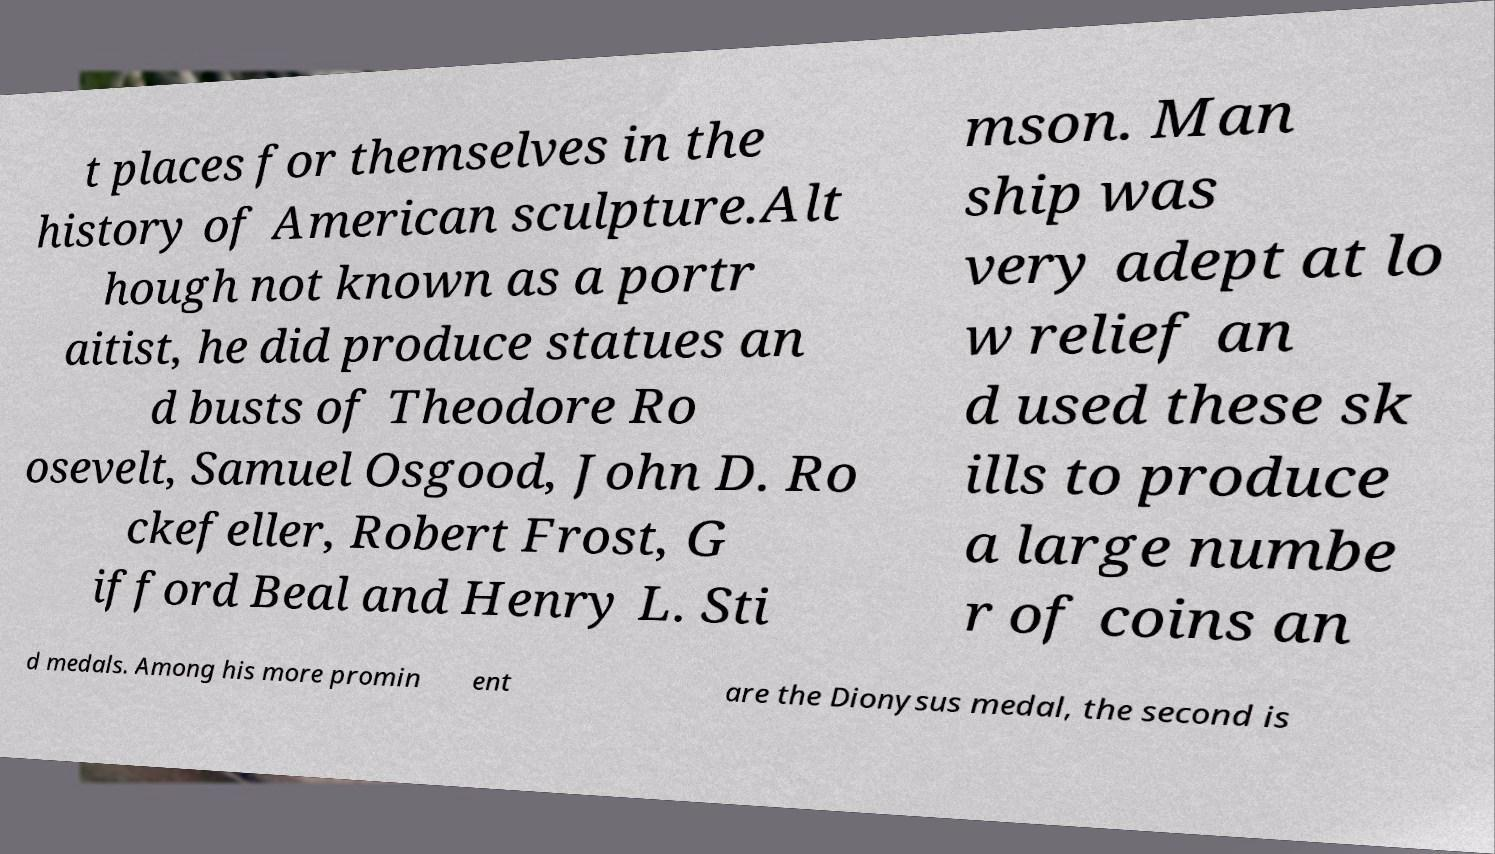Could you extract and type out the text from this image? t places for themselves in the history of American sculpture.Alt hough not known as a portr aitist, he did produce statues an d busts of Theodore Ro osevelt, Samuel Osgood, John D. Ro ckefeller, Robert Frost, G ifford Beal and Henry L. Sti mson. Man ship was very adept at lo w relief an d used these sk ills to produce a large numbe r of coins an d medals. Among his more promin ent are the Dionysus medal, the second is 